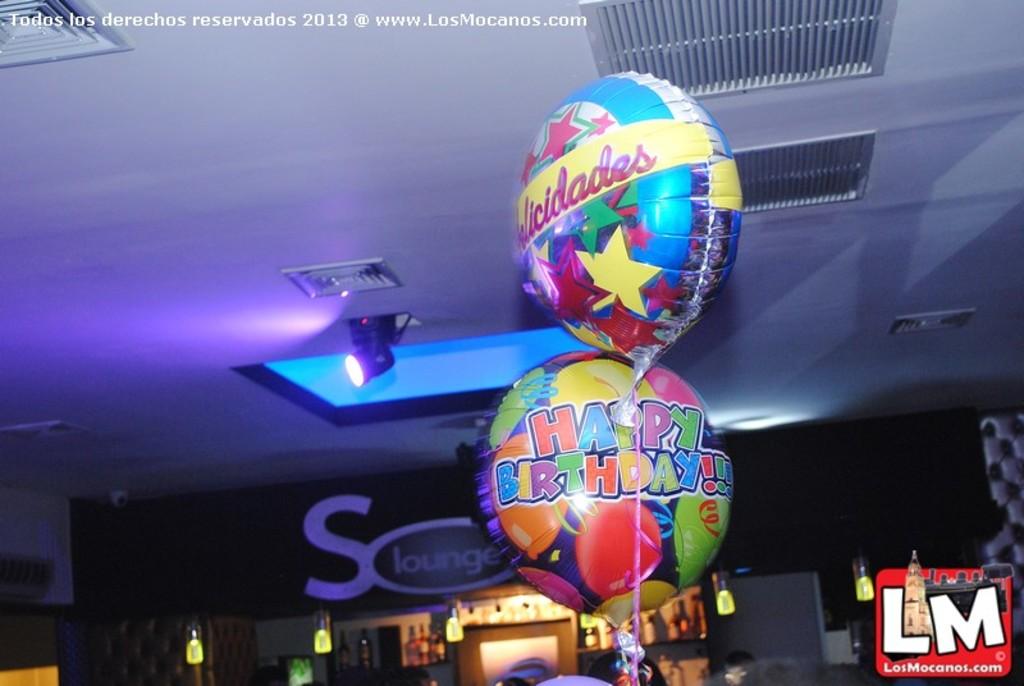Where are they at?
Give a very brief answer. S lounge. 